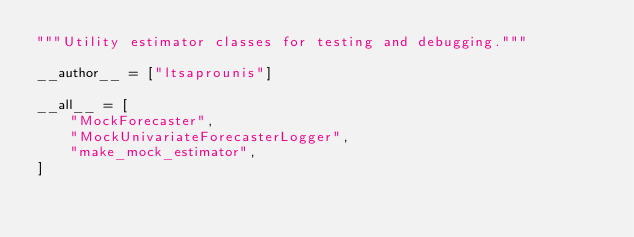<code> <loc_0><loc_0><loc_500><loc_500><_Python_>"""Utility estimator classes for testing and debugging."""

__author__ = ["ltsaprounis"]

__all__ = [
    "MockForecaster",
    "MockUnivariateForecasterLogger",
    "make_mock_estimator",
]
</code> 